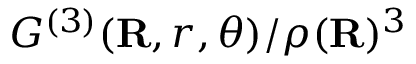<formula> <loc_0><loc_0><loc_500><loc_500>{ G ^ { ( 3 ) } } ( R , r , \theta ) / \rho ( R ) ^ { 3 }</formula> 